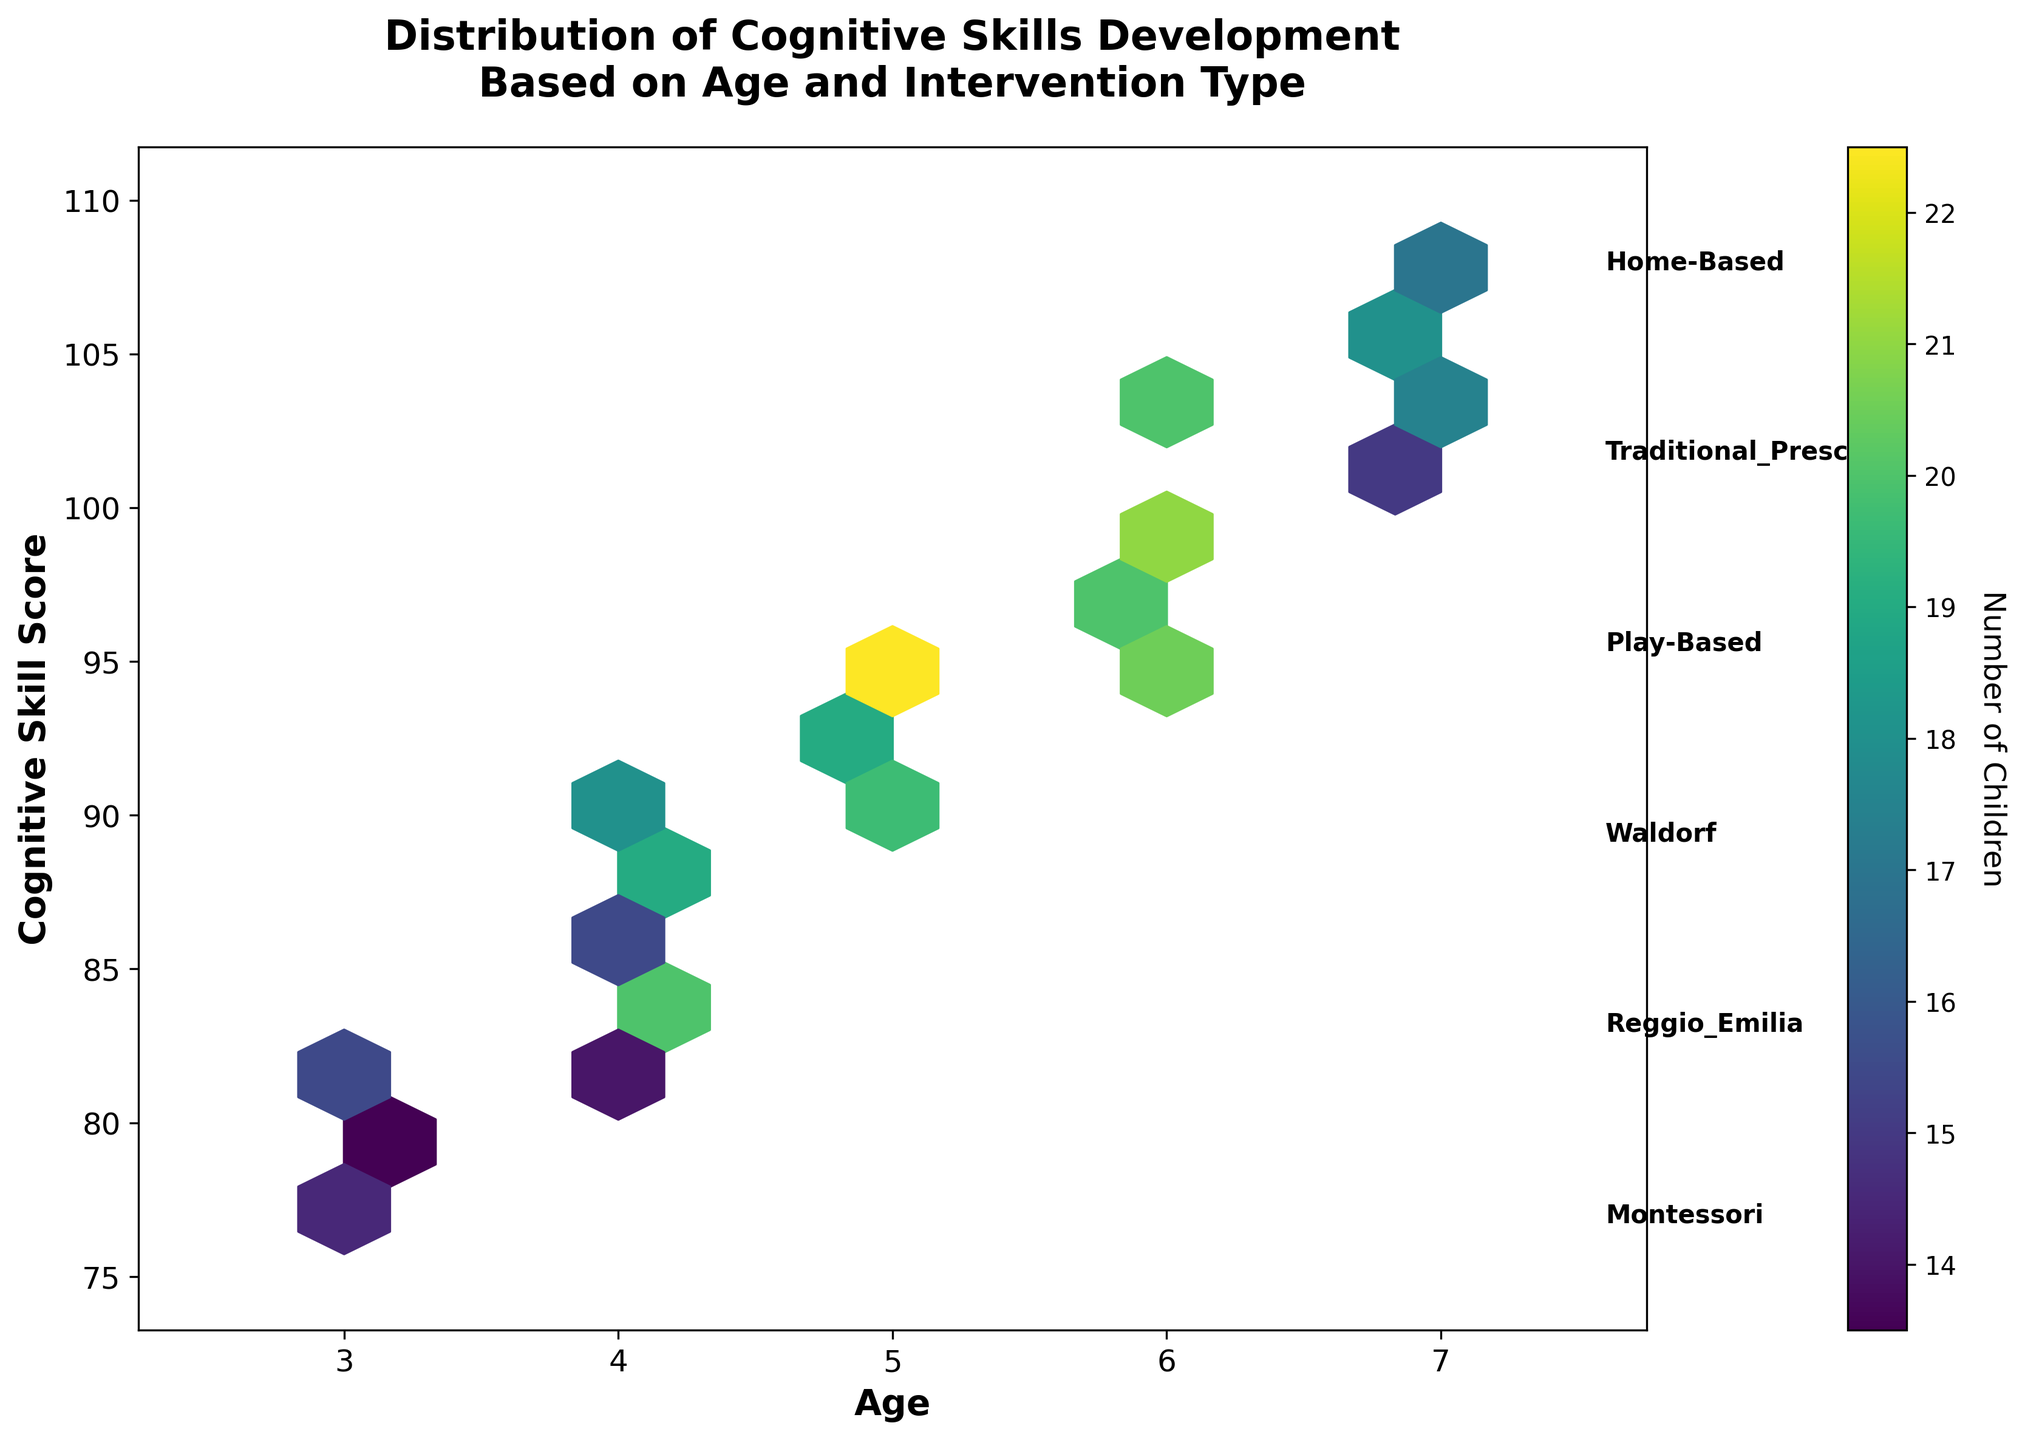What's the title of the figure? The title is typically located at the top of the plot and gives a summary of what the figure is about. In this case, it reads "Distribution of Cognitive Skills Development Based on Age and Intervention Type".
Answer: Distribution of Cognitive Skills Development Based on Age and Intervention Type What does the color intensity represent in the hexbin plot? In a hexbin plot, the color intensity usually indicates the density or concentration of points within each hexagon. Here, the colorbar shows that darker to lighter colors represent an increasing number of children.
Answer: Number of Children How does cognitive skill score change with age for children involved in Montessori interventions? You can observe the trend by looking at the positions of hexagons representing Montessori interventions across different ages. The cognitive skill score increases with age, going from roughly 82 at age 3 to 108 at age 7.
Answer: Increases Which age group has the highest cognitive skill score? To find the highest cognitive skill score, locate the uppermost hexagons on the y-axis. The age group that appears at the highest cognitive skill score is age 7.
Answer: Age 7 How does the number of children change with age and cognitive skill score? Notice the gradient color changes within the hexagons across different ages and skill scores. Generally, the number of children increases with both age and cognitive skill score, reaching its peak between ages 5 to 6 with cognitive scores around 94 to 100.
Answer: Increases Which intervention type has the most consistent improvement in cognitive skill scores as children age? By evaluating the annotations on the plot, Montessori intervention consistently shows a stable trend of cognitive skill score improvement as children age, without large deviations.
Answer: Montessori How do intervention types compare at age 5 in terms of cognitive skill score? At age 5, the cognitive skill scores for different interventions can be compared by looking at the y-values for age 5. Montessori and Play-Based interventions show higher cognitive skill scores (95 and 94, respectively), whereas Traditional Preschool and Home-Based are lower.
Answer: Montessori and Play-Based are higher What cognitive skill score range is most densely populated according to the hexbin plot? To identify the most densely populated range, observe where the color intensity is highest. This appears to be in the range of 88 to 102 cognitive skill scores.
Answer: 88 to 102 Compare the upper limits of cognitive skill scores for Reggio Emilia and Home-Based interventions. Compare the top y-values for the annotated Reggio Emilia and Home-Based interventions. Reggio Emilia reaches 105, whereas Home-Based interventions top at 101.
Answer: Reggio Emilia reaches higher What inference can be made about the effectiveness of Play-Based intervention over Traditional Preschool in cognitive skill development? Both interventions peak at age 7, but Play-Based interventions reach a higher score of 106 compared to 102 for Traditional Preschool, suggesting Play-Based may be more effective at improving cognitive skills.
Answer: Play-Based may be more effective 